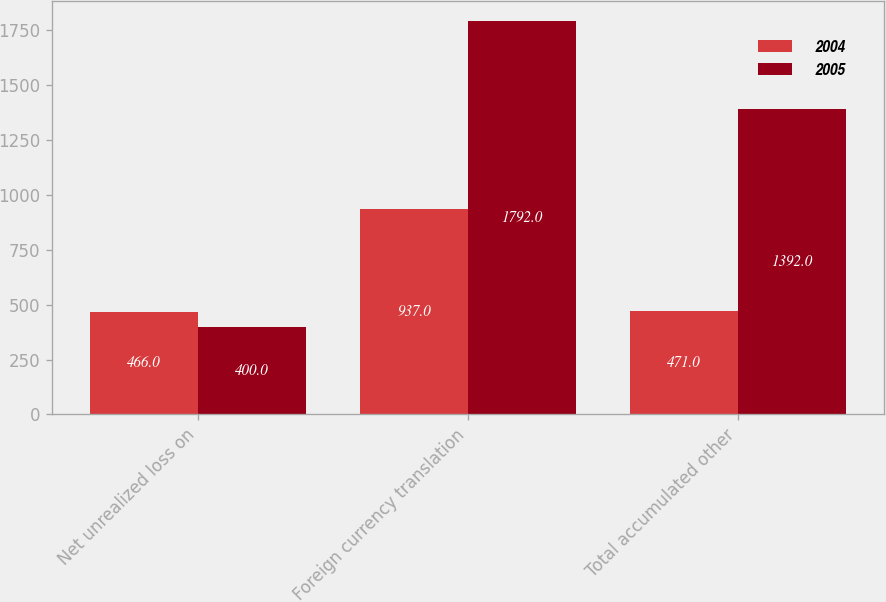<chart> <loc_0><loc_0><loc_500><loc_500><stacked_bar_chart><ecel><fcel>Net unrealized loss on<fcel>Foreign currency translation<fcel>Total accumulated other<nl><fcel>2004<fcel>466<fcel>937<fcel>471<nl><fcel>2005<fcel>400<fcel>1792<fcel>1392<nl></chart> 